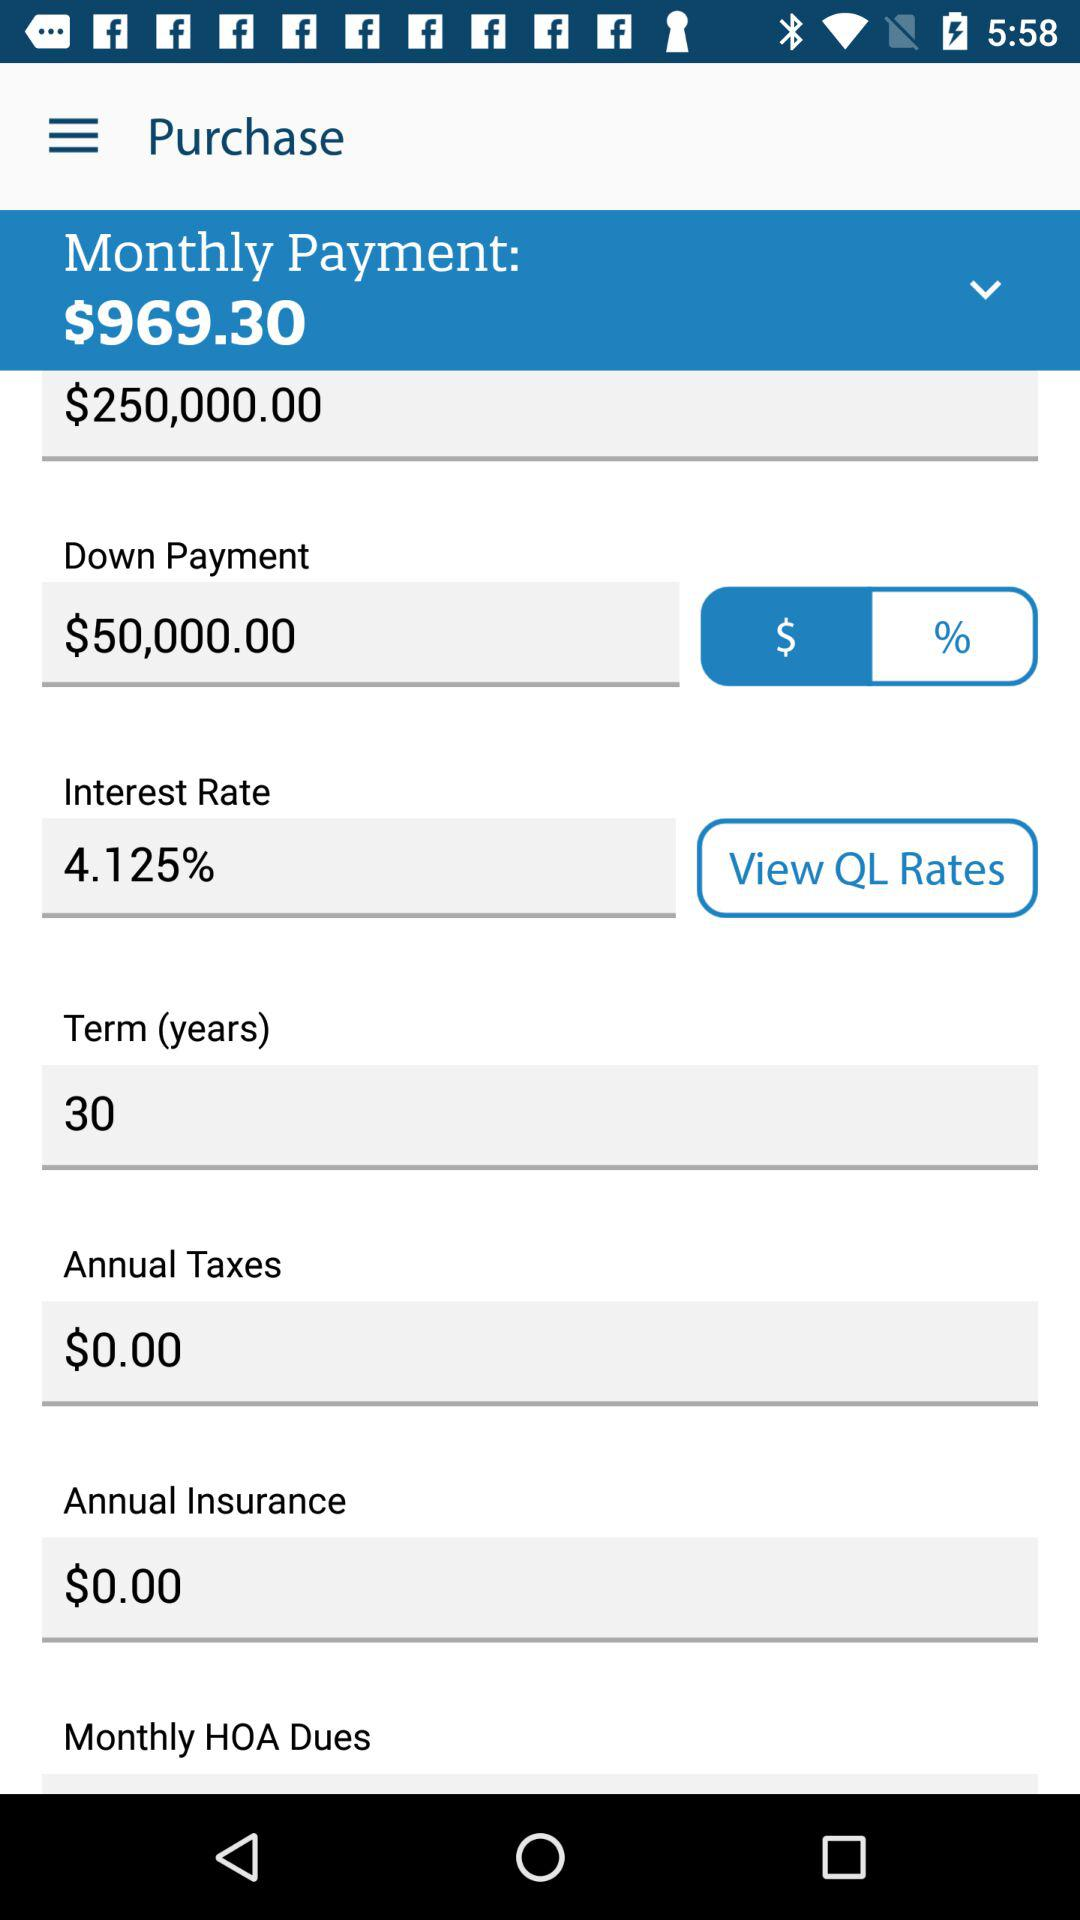What is the monthly payment amount? The monthly payment amount is $969.30. 